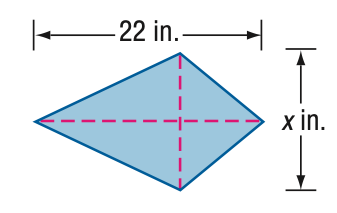Question: Find x. A = 92 in^2.
Choices:
A. 4.2
B. 6.3
C. 8.4
D. 10.5
Answer with the letter. Answer: C 